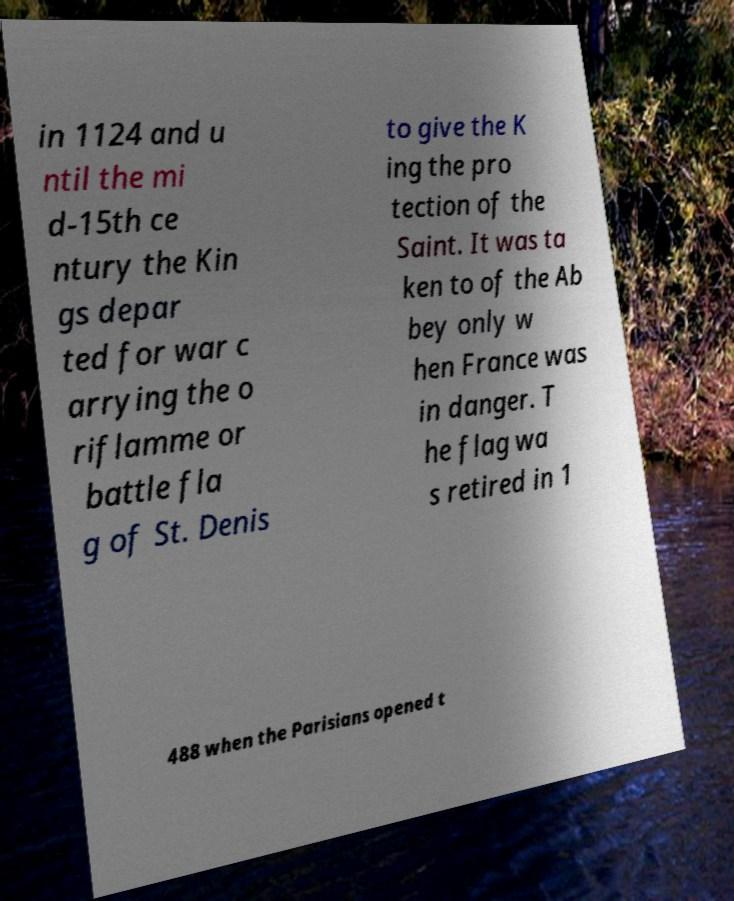Could you assist in decoding the text presented in this image and type it out clearly? in 1124 and u ntil the mi d-15th ce ntury the Kin gs depar ted for war c arrying the o riflamme or battle fla g of St. Denis to give the K ing the pro tection of the Saint. It was ta ken to of the Ab bey only w hen France was in danger. T he flag wa s retired in 1 488 when the Parisians opened t 